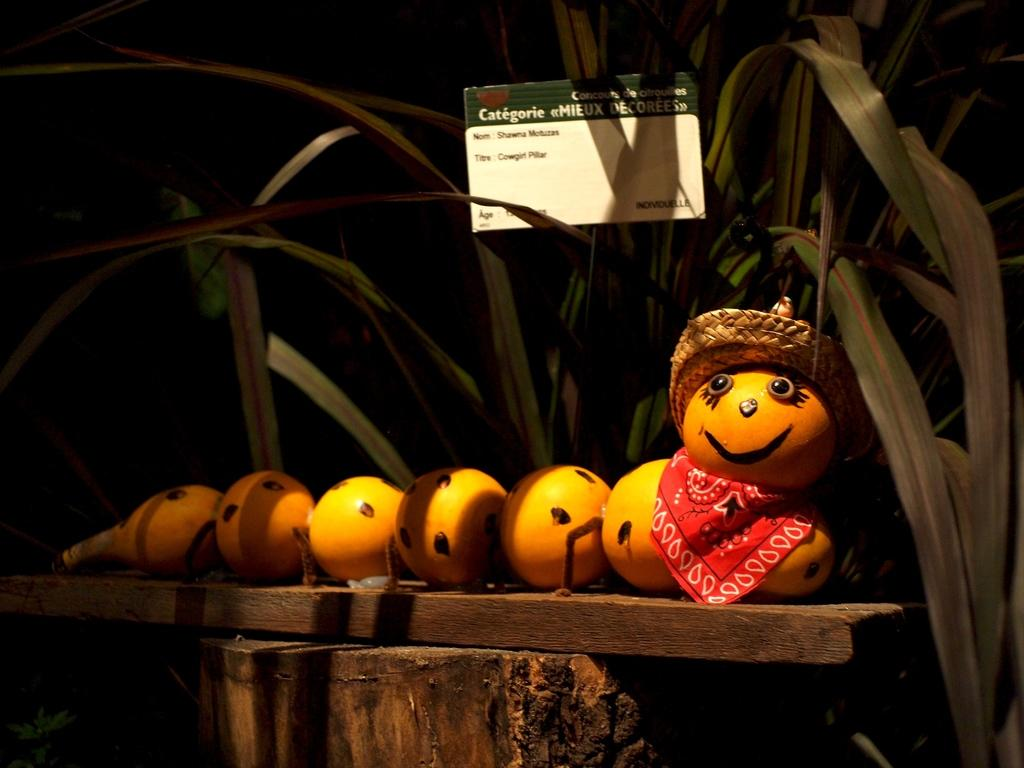What objects are on the wooden surface in the image? There are toys on a wooden surface in the image. What else can be seen in the image besides the toys? There is a board with text and plants in the image. What actor is performing in front of the window in the image? There is no actor or window present in the image. What type of stove is visible in the image? There is no stove present in the image. 